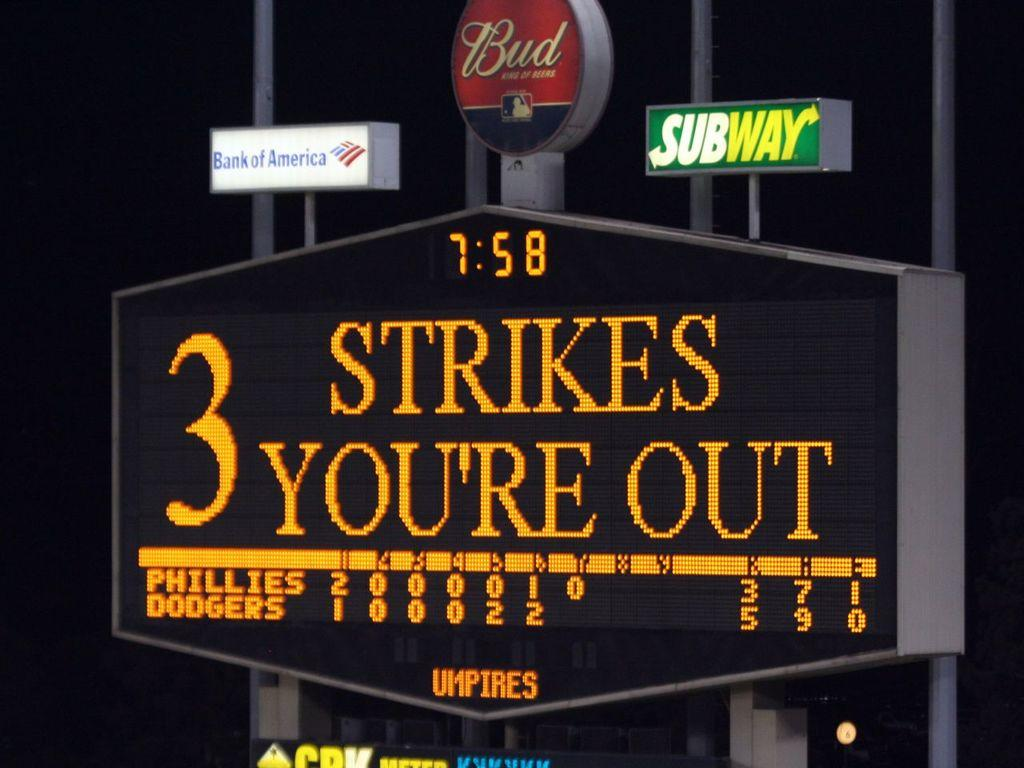<image>
Create a compact narrative representing the image presented. Someone just struck out at the Phillies and Dodgers game. 